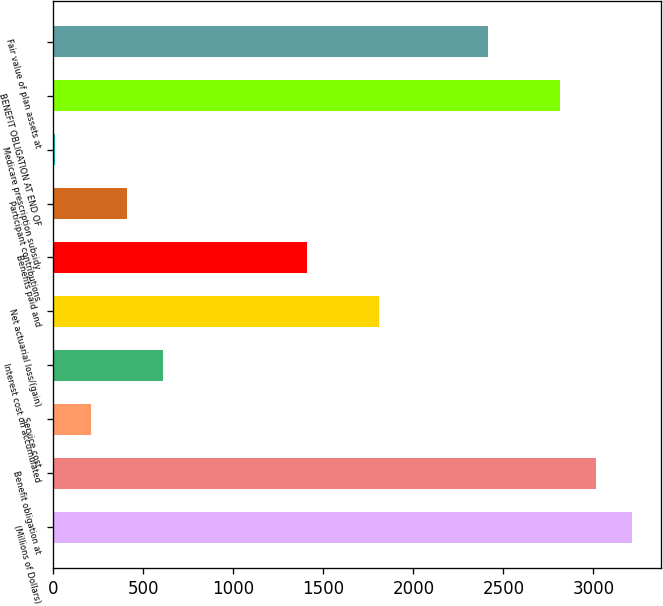<chart> <loc_0><loc_0><loc_500><loc_500><bar_chart><fcel>(Millions of Dollars)<fcel>Benefit obligation at<fcel>Service cost<fcel>Interest cost on accumulated<fcel>Net actuarial loss/(gain)<fcel>Benefits paid and<fcel>Participant contributions<fcel>Medicare prescription subsidy<fcel>BENEFIT OBLIGATION AT END OF<fcel>Fair value of plan assets at<nl><fcel>3214.4<fcel>3014<fcel>208.4<fcel>609.2<fcel>1811.6<fcel>1410.8<fcel>408.8<fcel>8<fcel>2813.6<fcel>2412.8<nl></chart> 